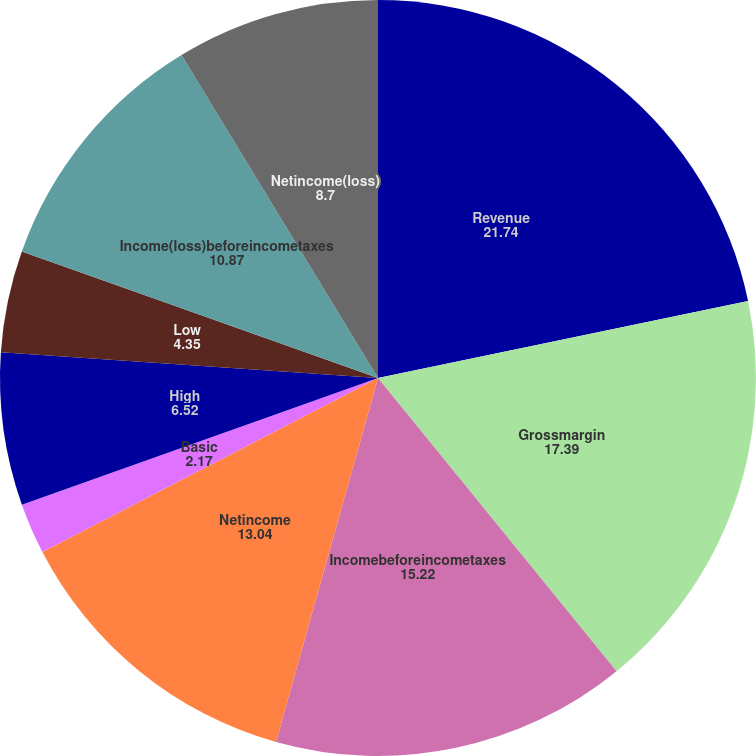Convert chart. <chart><loc_0><loc_0><loc_500><loc_500><pie_chart><fcel>Revenue<fcel>Grossmargin<fcel>Incomebeforeincometaxes<fcel>Netincome<fcel>Basic<fcel>Diluted<fcel>High<fcel>Low<fcel>Income(loss)beforeincometaxes<fcel>Netincome(loss)<nl><fcel>21.74%<fcel>17.39%<fcel>15.22%<fcel>13.04%<fcel>2.17%<fcel>0.0%<fcel>6.52%<fcel>4.35%<fcel>10.87%<fcel>8.7%<nl></chart> 